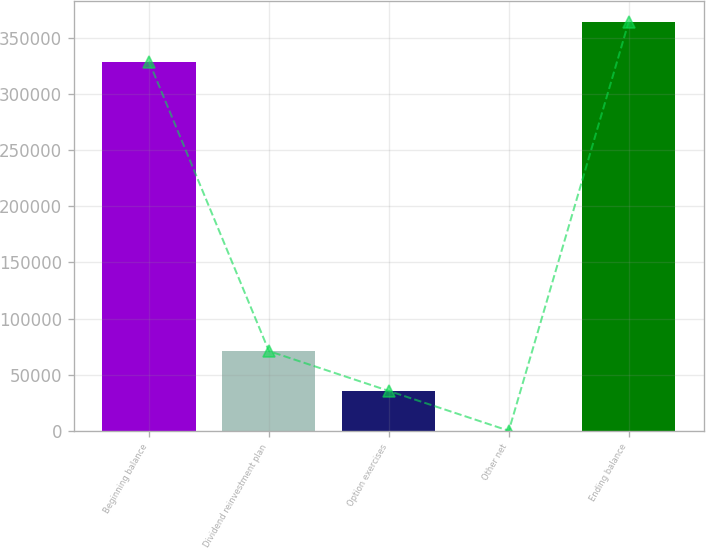<chart> <loc_0><loc_0><loc_500><loc_500><bar_chart><fcel>Beginning balance<fcel>Dividend reinvestment plan<fcel>Option exercises<fcel>Other net<fcel>Ending balance<nl><fcel>328790<fcel>71066.8<fcel>35602.9<fcel>139<fcel>364254<nl></chart> 